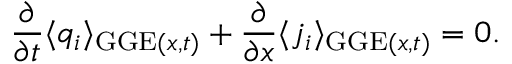<formula> <loc_0><loc_0><loc_500><loc_500>\frac { \partial } { \partial t } \langle q _ { i } \rangle _ { G G E ( x , t ) } + \frac { \partial } { \partial x } \langle j _ { i } \rangle _ { G G E ( x , t ) } = 0 .</formula> 